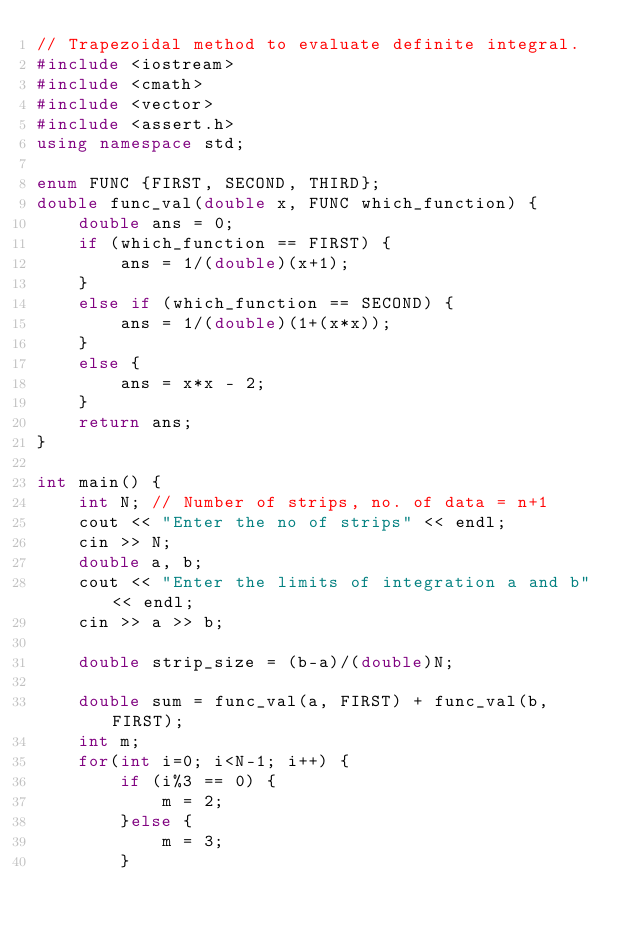<code> <loc_0><loc_0><loc_500><loc_500><_C++_>// Trapezoidal method to evaluate definite integral.
#include <iostream>
#include <cmath>
#include <vector>
#include <assert.h>
using namespace std;

enum FUNC {FIRST, SECOND, THIRD};
double func_val(double x, FUNC which_function) {
    double ans = 0;
    if (which_function == FIRST) {
        ans = 1/(double)(x+1);
    }
    else if (which_function == SECOND) {
        ans = 1/(double)(1+(x*x));
    }
    else {
        ans = x*x - 2;
    }
    return ans;
}

int main() {
    int N; // Number of strips, no. of data = n+1
    cout << "Enter the no of strips" << endl;
    cin >> N;
    double a, b;
    cout << "Enter the limits of integration a and b" << endl;
    cin >> a >> b;

    double strip_size = (b-a)/(double)N;

    double sum = func_val(a, FIRST) + func_val(b, FIRST);
    int m;
    for(int i=0; i<N-1; i++) {
        if (i%3 == 0) {
            m = 2;
        }else {
            m = 3;
        }
</code> 